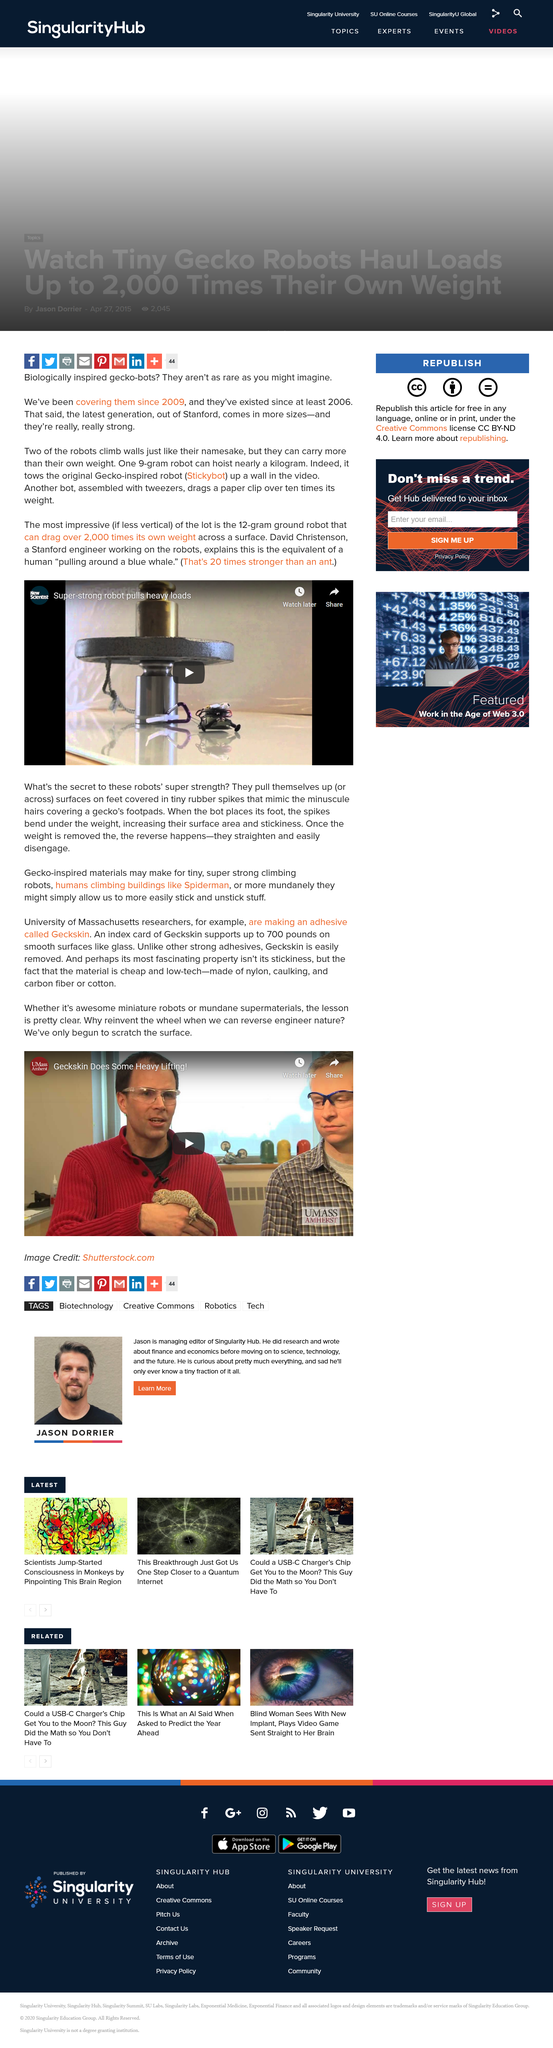Draw attention to some important aspects in this diagram. The comparison of a human pulling a blue whale and a 12-gram ground robot that can drag over 2,000 times its own weight across a surface is equivalent to a human trying to pull a blue whale with a toy car. The ground robot is capable of dragging a massive weight across a surface, an ability that is unmatched in the animal kingdom. The 12 gram robot that can pull more than 2,000 times its own weight is the most impressive robot mentioned. Geckskin, comprised of nylon, caulking, carbon fiber, and in some cases cotton, is a cutting-edge climbing aid that enables individuals to ascend vertical surfaces with ease and precision. Yes, Geckskin can be easily removed. The University of Massachusetts is developing an adhesive product called Geckskin, which will revolutionize the industry with its unique properties. 